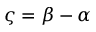Convert formula to latex. <formula><loc_0><loc_0><loc_500><loc_500>\varsigma = \beta - \alpha</formula> 